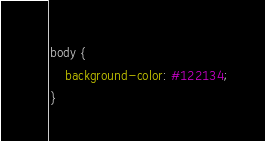<code> <loc_0><loc_0><loc_500><loc_500><_CSS_>body {
	background-color: #122134;
}</code> 